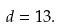Convert formula to latex. <formula><loc_0><loc_0><loc_500><loc_500>d = 1 3 .</formula> 